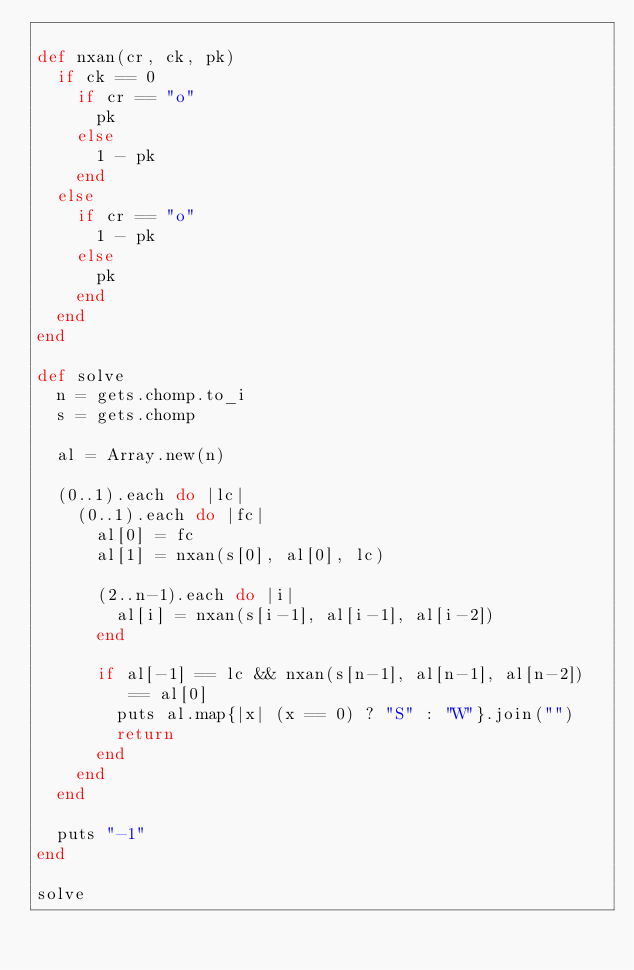Convert code to text. <code><loc_0><loc_0><loc_500><loc_500><_Ruby_>
def nxan(cr, ck, pk)
  if ck == 0
    if cr == "o"
      pk
    else
      1 - pk
    end
  else
    if cr == "o"
      1 - pk
    else
      pk
    end
  end
end

def solve
  n = gets.chomp.to_i
  s = gets.chomp

  al = Array.new(n)
  
  (0..1).each do |lc|
    (0..1).each do |fc|
      al[0] = fc
      al[1] = nxan(s[0], al[0], lc)
      
      (2..n-1).each do |i|
        al[i] = nxan(s[i-1], al[i-1], al[i-2])
      end

      if al[-1] == lc && nxan(s[n-1], al[n-1], al[n-2]) == al[0]
        puts al.map{|x| (x == 0) ? "S" : "W"}.join("")
        return
      end
    end
  end

  puts "-1"
end

solve

</code> 